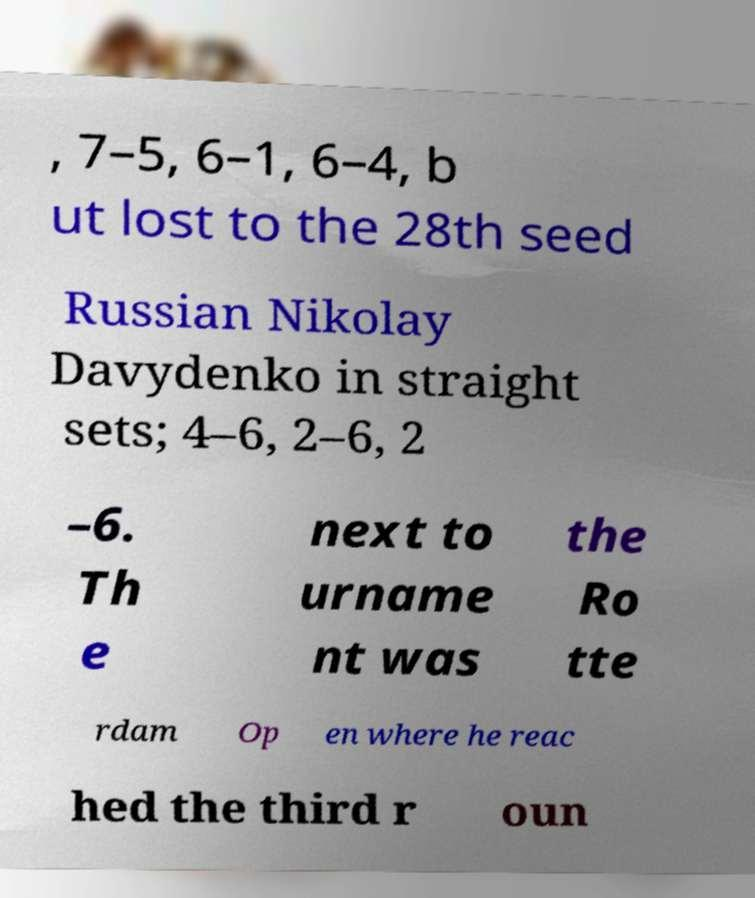Could you assist in decoding the text presented in this image and type it out clearly? , 7–5, 6–1, 6–4, b ut lost to the 28th seed Russian Nikolay Davydenko in straight sets; 4–6, 2–6, 2 –6. Th e next to urname nt was the Ro tte rdam Op en where he reac hed the third r oun 